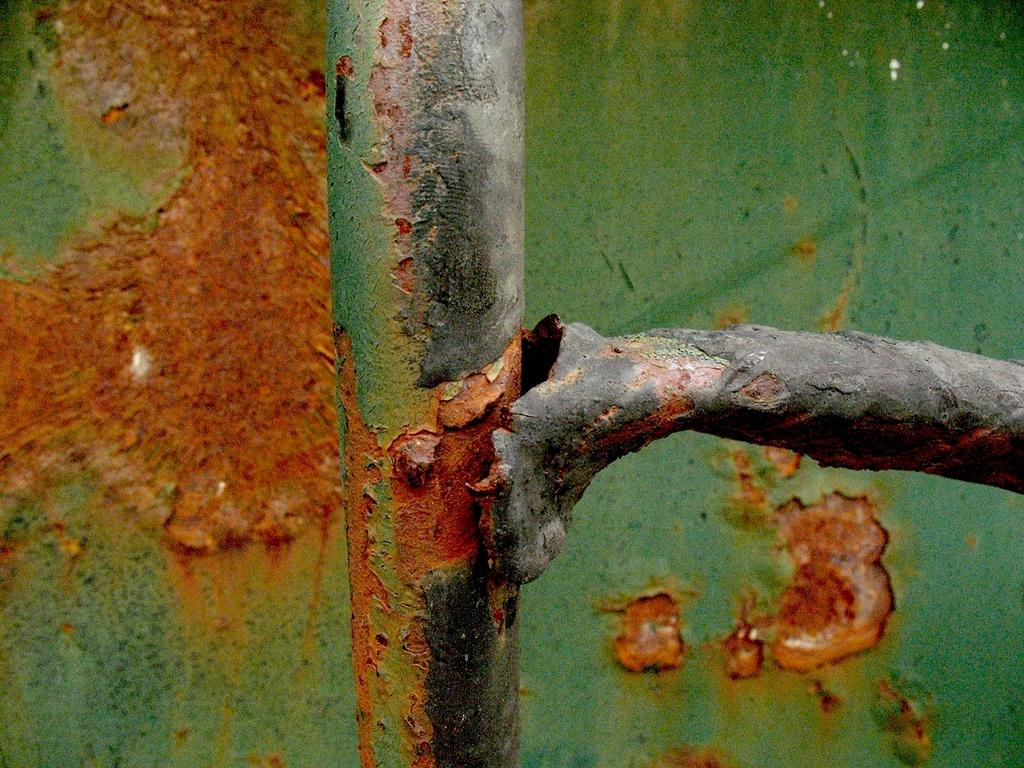What type of material is the object in the image made of? The object in the image is made of metal. What can be seen behind the metal object in the image? There is a wall visible behind the metal object. How many fingers can be seen on the metal object in the image? There are no fingers present on the metal object in the image. Is there a deer visible in the image? No, there is no deer present in the image. 